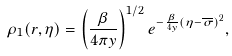<formula> <loc_0><loc_0><loc_500><loc_500>\rho _ { 1 } ( { r } , \eta ) = \left ( \frac { \beta } { 4 \pi y } \right ) ^ { 1 / 2 } e ^ { - \frac { \beta } { 4 y } ( \eta - \overline { \sigma } ) ^ { 2 } } ,</formula> 